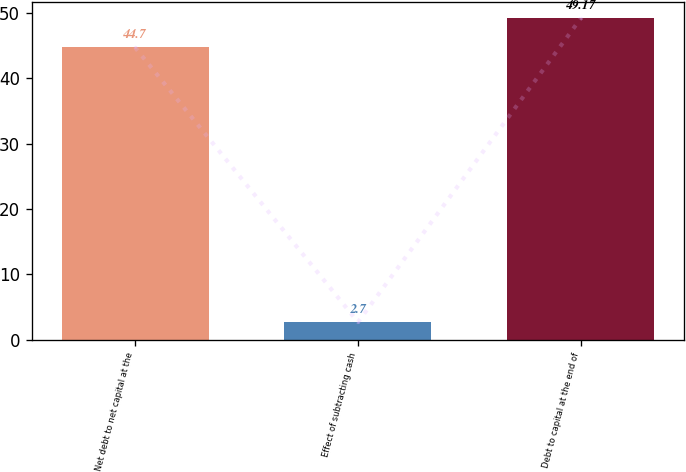Convert chart. <chart><loc_0><loc_0><loc_500><loc_500><bar_chart><fcel>Net debt to net capital at the<fcel>Effect of subtracting cash<fcel>Debt to capital at the end of<nl><fcel>44.7<fcel>2.7<fcel>49.17<nl></chart> 